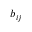Convert formula to latex. <formula><loc_0><loc_0><loc_500><loc_500>b _ { i j }</formula> 